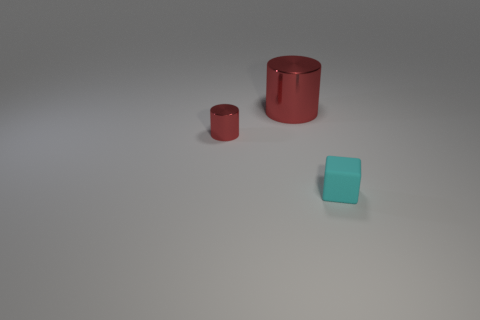What number of big cylinders are the same color as the small metallic cylinder?
Provide a short and direct response. 1. There is a cylinder in front of the big red cylinder; what is it made of?
Your answer should be compact. Metal. There is a small red shiny thing; is it the same shape as the small thing on the right side of the large red metal cylinder?
Your answer should be compact. No. There is a metal thing that is behind the thing that is on the left side of the large thing; how many tiny metallic objects are to the right of it?
Provide a short and direct response. 0. There is another shiny thing that is the same shape as the tiny red metal object; what is its color?
Ensure brevity in your answer.  Red. Is there any other thing that is the same shape as the big thing?
Keep it short and to the point. Yes. What number of blocks are large red things or small red shiny objects?
Your answer should be compact. 0. What shape is the big shiny object?
Give a very brief answer. Cylinder. There is a large metal object; are there any blocks on the left side of it?
Provide a short and direct response. No. Does the tiny cyan thing have the same material as the cylinder behind the tiny red metallic object?
Offer a very short reply. No. 